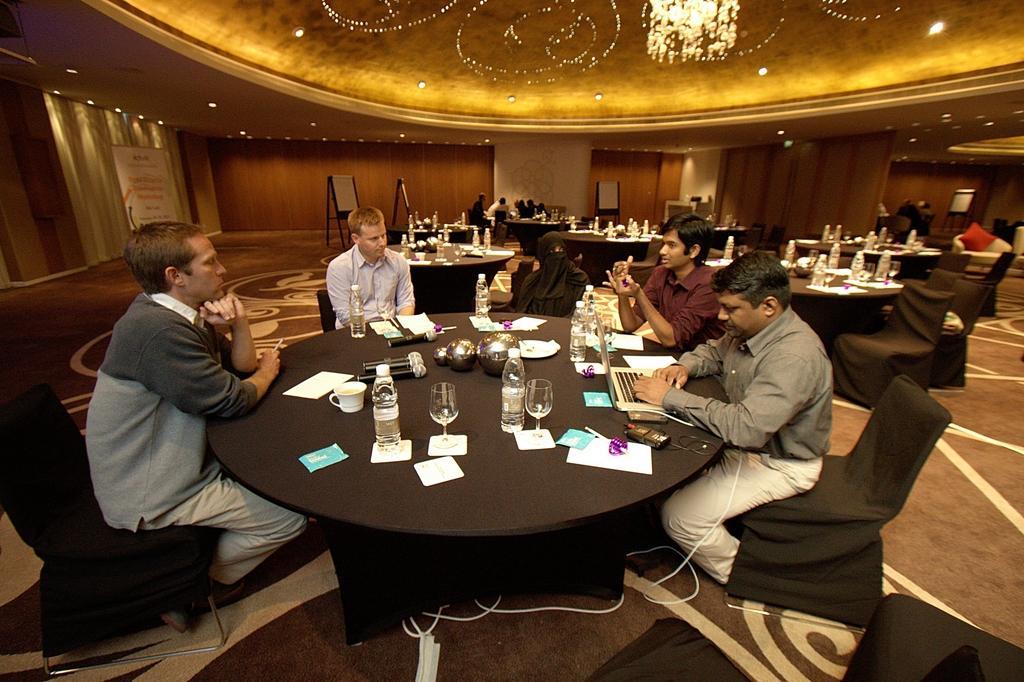How would you summarize this image in a sentence or two? In the image we can see that,there are five people sitting around a table. This is a chair. This is a table. On the table we can see wine glass, water bottle, tea cup and microphones. This is a poster and curtains. There are many other people around. 